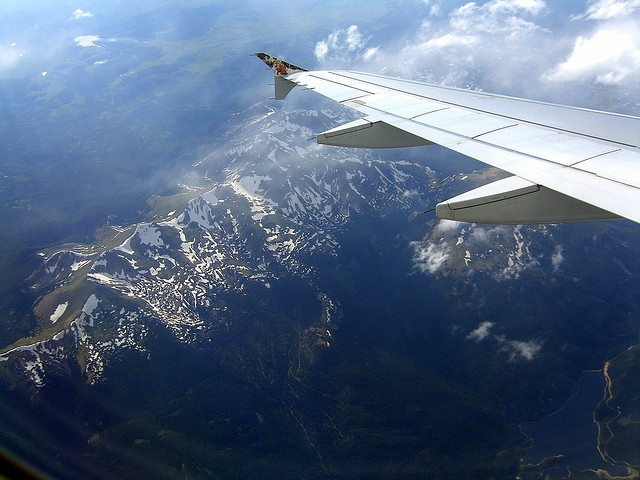Describe the objects in this image and their specific colors. I can see a airplane in lightblue, white, gray, lightgray, and darkgray tones in this image. 